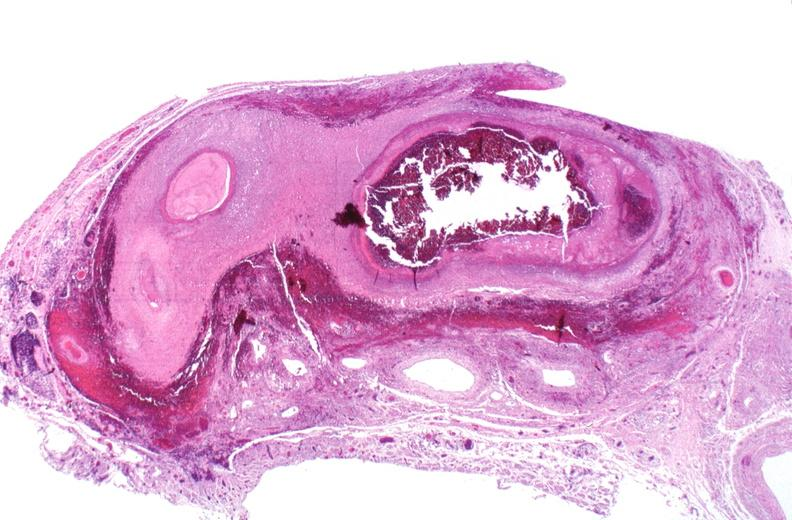does this image show polyarteritis nodosa?
Answer the question using a single word or phrase. Yes 